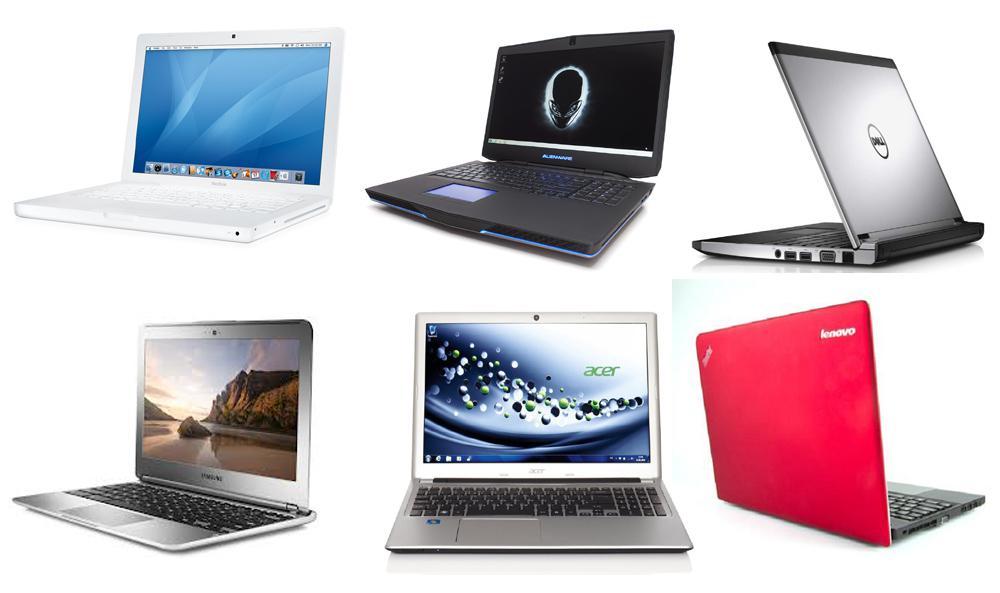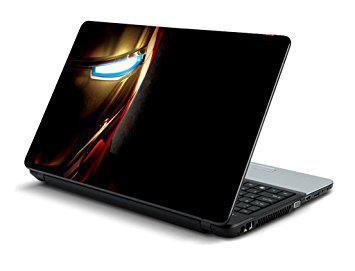The first image is the image on the left, the second image is the image on the right. Given the left and right images, does the statement "At least five laptop computer styles are arrayed in one image." hold true? Answer yes or no. Yes. The first image is the image on the left, the second image is the image on the right. For the images shown, is this caption "An image shows at least five laptops." true? Answer yes or no. Yes. 